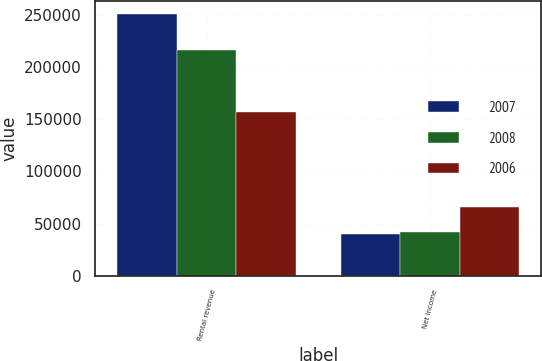<chart> <loc_0><loc_0><loc_500><loc_500><stacked_bar_chart><ecel><fcel>Rental revenue<fcel>Net income<nl><fcel>2007<fcel>250312<fcel>40437<nl><fcel>2008<fcel>215855<fcel>41725<nl><fcel>2006<fcel>157186<fcel>65985<nl></chart> 